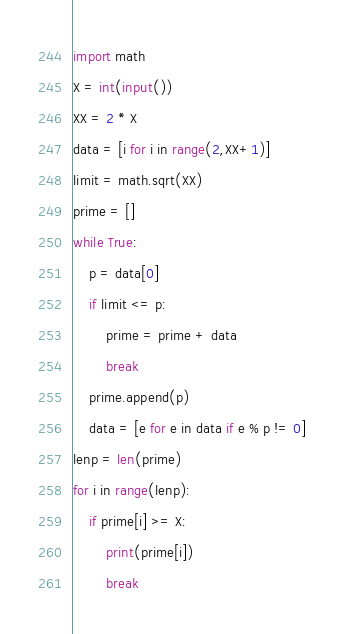Convert code to text. <code><loc_0><loc_0><loc_500><loc_500><_Python_>import math
X = int(input())
XX = 2 * X
data = [i for i in range(2,XX+1)]
limit = math.sqrt(XX)
prime = []
while True:
    p = data[0]
    if limit <= p:
        prime = prime + data
        break
    prime.append(p)
    data = [e for e in data if e % p != 0]
lenp = len(prime)
for i in range(lenp):
    if prime[i] >= X:
        print(prime[i])
        break</code> 